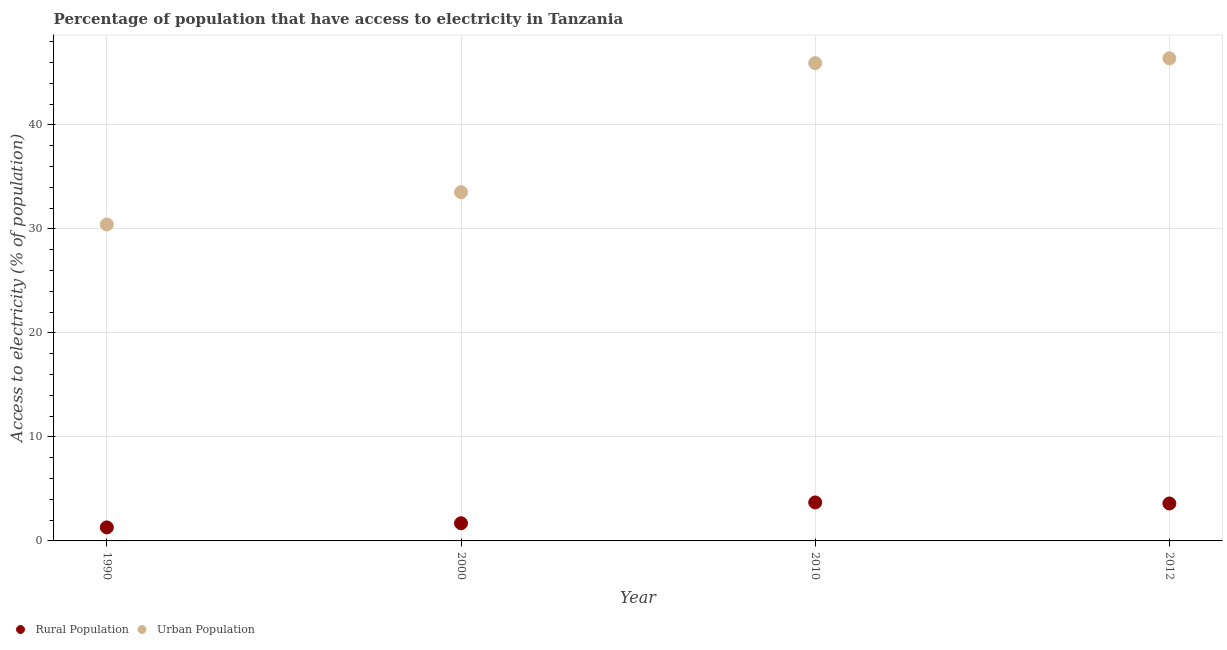What is the percentage of urban population having access to electricity in 2012?
Give a very brief answer. 46.4. Across all years, what is the maximum percentage of urban population having access to electricity?
Provide a succinct answer. 46.4. Across all years, what is the minimum percentage of rural population having access to electricity?
Your response must be concise. 1.3. In which year was the percentage of urban population having access to electricity maximum?
Your answer should be compact. 2012. What is the difference between the percentage of urban population having access to electricity in 1990 and that in 2000?
Offer a very short reply. -3.1. What is the difference between the percentage of rural population having access to electricity in 1990 and the percentage of urban population having access to electricity in 2012?
Your response must be concise. -45.1. What is the average percentage of rural population having access to electricity per year?
Make the answer very short. 2.58. In the year 2000, what is the difference between the percentage of rural population having access to electricity and percentage of urban population having access to electricity?
Your response must be concise. -31.83. In how many years, is the percentage of rural population having access to electricity greater than 44 %?
Offer a very short reply. 0. What is the ratio of the percentage of rural population having access to electricity in 2000 to that in 2010?
Keep it short and to the point. 0.46. What is the difference between the highest and the second highest percentage of rural population having access to electricity?
Offer a terse response. 0.1. What is the difference between the highest and the lowest percentage of urban population having access to electricity?
Your response must be concise. 15.97. Does the percentage of urban population having access to electricity monotonically increase over the years?
Your answer should be compact. Yes. Is the percentage of rural population having access to electricity strictly less than the percentage of urban population having access to electricity over the years?
Make the answer very short. Yes. How many dotlines are there?
Offer a very short reply. 2. How many years are there in the graph?
Offer a terse response. 4. Are the values on the major ticks of Y-axis written in scientific E-notation?
Your response must be concise. No. Does the graph contain grids?
Give a very brief answer. Yes. Where does the legend appear in the graph?
Provide a short and direct response. Bottom left. How many legend labels are there?
Keep it short and to the point. 2. What is the title of the graph?
Offer a terse response. Percentage of population that have access to electricity in Tanzania. Does "Rural" appear as one of the legend labels in the graph?
Ensure brevity in your answer.  No. What is the label or title of the Y-axis?
Provide a short and direct response. Access to electricity (% of population). What is the Access to electricity (% of population) of Rural Population in 1990?
Offer a terse response. 1.3. What is the Access to electricity (% of population) of Urban Population in 1990?
Make the answer very short. 30.43. What is the Access to electricity (% of population) in Rural Population in 2000?
Provide a short and direct response. 1.7. What is the Access to electricity (% of population) in Urban Population in 2000?
Your response must be concise. 33.53. What is the Access to electricity (% of population) of Urban Population in 2010?
Keep it short and to the point. 45.94. What is the Access to electricity (% of population) in Urban Population in 2012?
Make the answer very short. 46.4. Across all years, what is the maximum Access to electricity (% of population) in Rural Population?
Give a very brief answer. 3.7. Across all years, what is the maximum Access to electricity (% of population) in Urban Population?
Your response must be concise. 46.4. Across all years, what is the minimum Access to electricity (% of population) in Rural Population?
Your answer should be compact. 1.3. Across all years, what is the minimum Access to electricity (% of population) in Urban Population?
Your response must be concise. 30.43. What is the total Access to electricity (% of population) in Urban Population in the graph?
Provide a succinct answer. 156.29. What is the difference between the Access to electricity (% of population) in Rural Population in 1990 and that in 2000?
Your response must be concise. -0.4. What is the difference between the Access to electricity (% of population) in Urban Population in 1990 and that in 2000?
Your response must be concise. -3.1. What is the difference between the Access to electricity (% of population) in Urban Population in 1990 and that in 2010?
Provide a succinct answer. -15.51. What is the difference between the Access to electricity (% of population) in Urban Population in 1990 and that in 2012?
Give a very brief answer. -15.97. What is the difference between the Access to electricity (% of population) in Rural Population in 2000 and that in 2010?
Give a very brief answer. -2. What is the difference between the Access to electricity (% of population) in Urban Population in 2000 and that in 2010?
Give a very brief answer. -12.41. What is the difference between the Access to electricity (% of population) of Urban Population in 2000 and that in 2012?
Your answer should be very brief. -12.87. What is the difference between the Access to electricity (% of population) in Urban Population in 2010 and that in 2012?
Offer a very short reply. -0.46. What is the difference between the Access to electricity (% of population) in Rural Population in 1990 and the Access to electricity (% of population) in Urban Population in 2000?
Make the answer very short. -32.23. What is the difference between the Access to electricity (% of population) in Rural Population in 1990 and the Access to electricity (% of population) in Urban Population in 2010?
Your response must be concise. -44.64. What is the difference between the Access to electricity (% of population) of Rural Population in 1990 and the Access to electricity (% of population) of Urban Population in 2012?
Offer a terse response. -45.1. What is the difference between the Access to electricity (% of population) in Rural Population in 2000 and the Access to electricity (% of population) in Urban Population in 2010?
Ensure brevity in your answer.  -44.24. What is the difference between the Access to electricity (% of population) in Rural Population in 2000 and the Access to electricity (% of population) in Urban Population in 2012?
Your response must be concise. -44.7. What is the difference between the Access to electricity (% of population) in Rural Population in 2010 and the Access to electricity (% of population) in Urban Population in 2012?
Provide a succinct answer. -42.7. What is the average Access to electricity (% of population) of Rural Population per year?
Keep it short and to the point. 2.58. What is the average Access to electricity (% of population) in Urban Population per year?
Offer a very short reply. 39.07. In the year 1990, what is the difference between the Access to electricity (% of population) of Rural Population and Access to electricity (% of population) of Urban Population?
Your answer should be very brief. -29.13. In the year 2000, what is the difference between the Access to electricity (% of population) in Rural Population and Access to electricity (% of population) in Urban Population?
Your answer should be very brief. -31.83. In the year 2010, what is the difference between the Access to electricity (% of population) of Rural Population and Access to electricity (% of population) of Urban Population?
Ensure brevity in your answer.  -42.24. In the year 2012, what is the difference between the Access to electricity (% of population) in Rural Population and Access to electricity (% of population) in Urban Population?
Give a very brief answer. -42.8. What is the ratio of the Access to electricity (% of population) of Rural Population in 1990 to that in 2000?
Offer a terse response. 0.76. What is the ratio of the Access to electricity (% of population) in Urban Population in 1990 to that in 2000?
Offer a terse response. 0.91. What is the ratio of the Access to electricity (% of population) of Rural Population in 1990 to that in 2010?
Your response must be concise. 0.35. What is the ratio of the Access to electricity (% of population) of Urban Population in 1990 to that in 2010?
Make the answer very short. 0.66. What is the ratio of the Access to electricity (% of population) in Rural Population in 1990 to that in 2012?
Provide a short and direct response. 0.36. What is the ratio of the Access to electricity (% of population) in Urban Population in 1990 to that in 2012?
Offer a terse response. 0.66. What is the ratio of the Access to electricity (% of population) in Rural Population in 2000 to that in 2010?
Provide a succinct answer. 0.46. What is the ratio of the Access to electricity (% of population) of Urban Population in 2000 to that in 2010?
Make the answer very short. 0.73. What is the ratio of the Access to electricity (% of population) of Rural Population in 2000 to that in 2012?
Your response must be concise. 0.47. What is the ratio of the Access to electricity (% of population) of Urban Population in 2000 to that in 2012?
Your answer should be compact. 0.72. What is the ratio of the Access to electricity (% of population) of Rural Population in 2010 to that in 2012?
Offer a terse response. 1.03. What is the ratio of the Access to electricity (% of population) of Urban Population in 2010 to that in 2012?
Your response must be concise. 0.99. What is the difference between the highest and the second highest Access to electricity (% of population) of Urban Population?
Offer a very short reply. 0.46. What is the difference between the highest and the lowest Access to electricity (% of population) of Rural Population?
Offer a terse response. 2.4. What is the difference between the highest and the lowest Access to electricity (% of population) of Urban Population?
Make the answer very short. 15.97. 